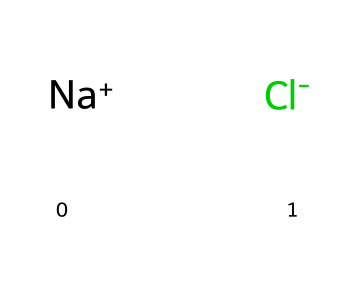What elements are present in this chemical? The SMILES representation indicates the presence of sodium (Na) and chlorine (Cl) as individual ions. Sodium is the positively charged cation ([Na+]) and chlorine is the negatively charged anion ([Cl-]).
Answer: sodium and chlorine How many atoms are represented in this SMILES? There are two distinct atoms present in the SMILES. The sodium (Na) and chlorine (Cl) are counted as individual atoms in the molecule.
Answer: 2 What is the overall charge of this molecule? The presence of [Na+] indicates a positive charge from the sodium ion, while [Cl-] indicates a negative charge from the chloride ion. These charges balance each other out, resulting in a neutral molecule overall.
Answer: neutral What type of bond exists between sodium and chloride? Sodium chloride forms an ionic bond due to the electrostatic attraction between the positively charged sodium ion and the negatively charged chloride ion.
Answer: ionic bond In what form does this substance typically appear in sports drinks? Sodium chloride is usually present in the form of dissolved ions in aqueous solutions, contributing to the electrolyte content of sports drinks.
Answer: dissolved ions Why is sodium chloride important in sports drinks? Sodium chloride helps to maintain electrolyte balance and hydration, which is crucial for athletes during physical activities to prevent cramps and dehydration.
Answer: hydration 